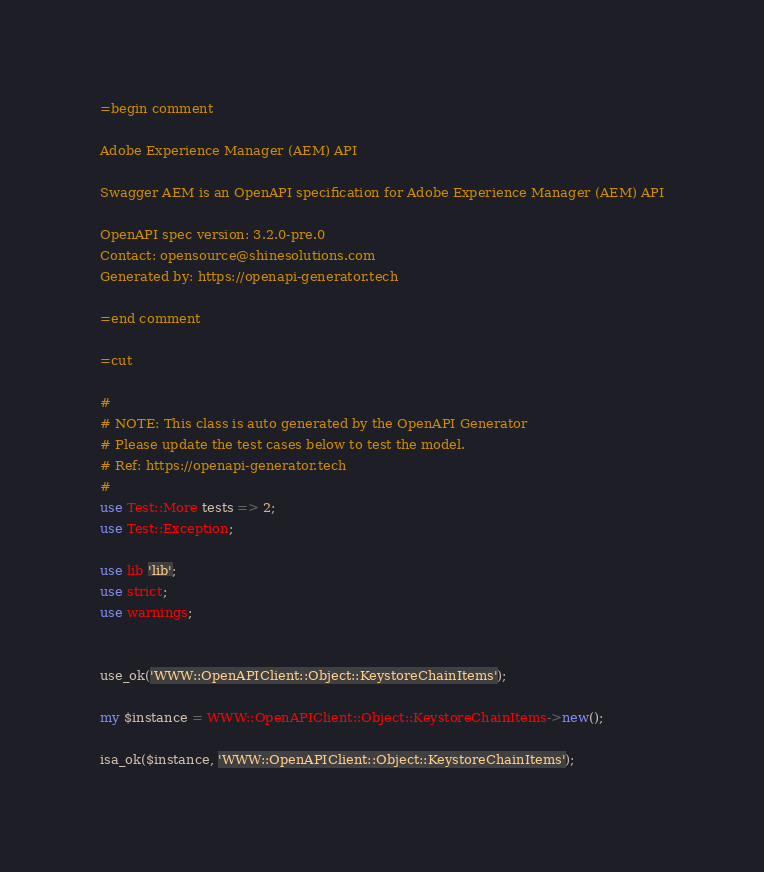Convert code to text. <code><loc_0><loc_0><loc_500><loc_500><_Perl_>=begin comment

Adobe Experience Manager (AEM) API

Swagger AEM is an OpenAPI specification for Adobe Experience Manager (AEM) API

OpenAPI spec version: 3.2.0-pre.0
Contact: opensource@shinesolutions.com
Generated by: https://openapi-generator.tech

=end comment

=cut

#
# NOTE: This class is auto generated by the OpenAPI Generator
# Please update the test cases below to test the model.
# Ref: https://openapi-generator.tech
#
use Test::More tests => 2;
use Test::Exception;

use lib 'lib';
use strict;
use warnings;


use_ok('WWW::OpenAPIClient::Object::KeystoreChainItems');

my $instance = WWW::OpenAPIClient::Object::KeystoreChainItems->new();

isa_ok($instance, 'WWW::OpenAPIClient::Object::KeystoreChainItems');

</code> 